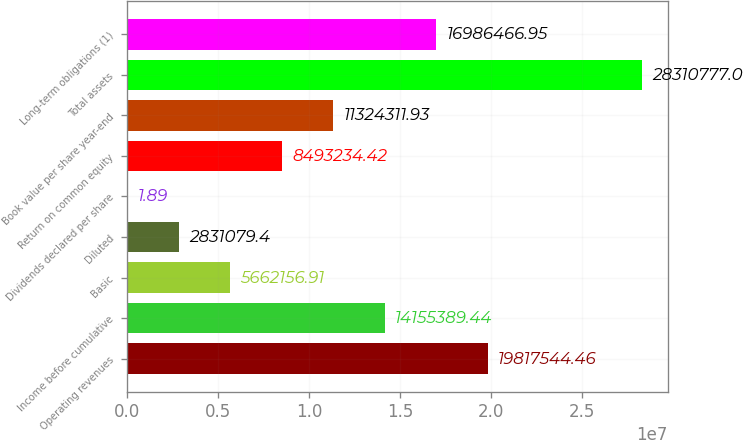Convert chart. <chart><loc_0><loc_0><loc_500><loc_500><bar_chart><fcel>Operating revenues<fcel>Income before cumulative<fcel>Basic<fcel>Diluted<fcel>Dividends declared per share<fcel>Return on common equity<fcel>Book value per share year-end<fcel>Total assets<fcel>Long-term obligations (1)<nl><fcel>1.98175e+07<fcel>1.41554e+07<fcel>5.66216e+06<fcel>2.83108e+06<fcel>1.89<fcel>8.49323e+06<fcel>1.13243e+07<fcel>2.83108e+07<fcel>1.69865e+07<nl></chart> 